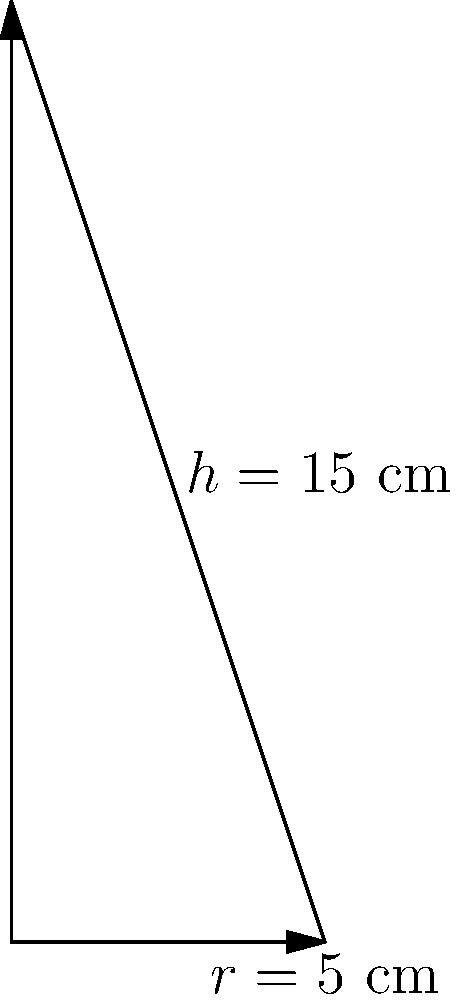A biodegradable conical planter for seedlings has a height of 15 cm and a base radius of 5 cm. Calculate the volume of this planter to determine the amount of biodegradable material needed for its production. Round your answer to the nearest cubic centimeter. To calculate the volume of a cone, we use the formula:

$$V = \frac{1}{3}\pi r^2 h$$

Where:
$V$ = volume
$r$ = radius of the base
$h$ = height of the cone

Given:
$r = 5$ cm
$h = 15$ cm

Step 1: Substitute the values into the formula:
$$V = \frac{1}{3}\pi (5\text{ cm})^2 (15\text{ cm})$$

Step 2: Calculate the squared radius:
$$V = \frac{1}{3}\pi (25\text{ cm}^2) (15\text{ cm})$$

Step 3: Multiply the values inside the parentheses:
$$V = \frac{1}{3}\pi (375\text{ cm}^3)$$

Step 4: Multiply by $\pi$ and simplify:
$$V = 125\pi\text{ cm}^3$$

Step 5: Calculate the final value (using 3.14159 for $\pi$):
$$V = 125 \times 3.14159 = 392.69875\text{ cm}^3$$

Step 6: Round to the nearest cubic centimeter:
$$V \approx 393\text{ cm}^3$$
Answer: 393 cm³ 